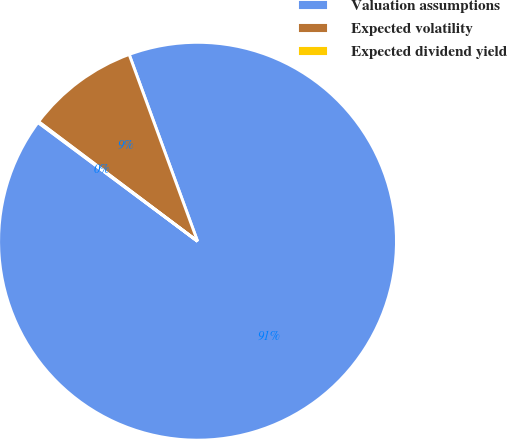<chart> <loc_0><loc_0><loc_500><loc_500><pie_chart><fcel>Valuation assumptions<fcel>Expected volatility<fcel>Expected dividend yield<nl><fcel>90.77%<fcel>9.15%<fcel>0.08%<nl></chart> 